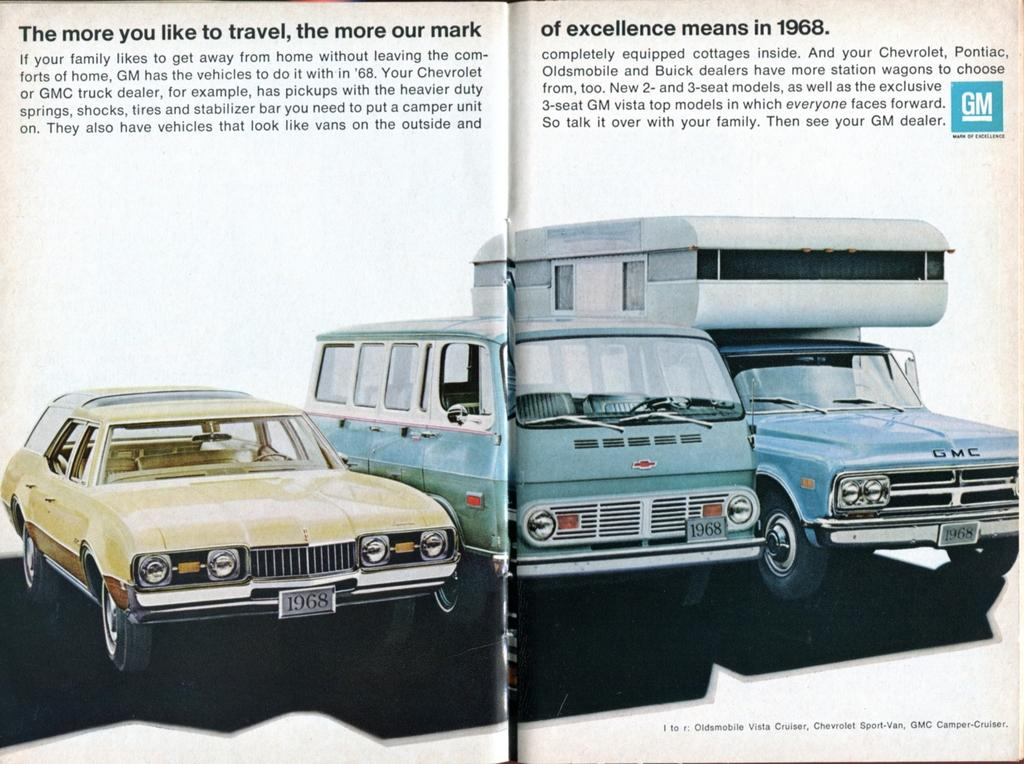Provide a one-sentence caption for the provided image. A 2-page GM ad from 1968 promotes their mark of excellence and features several vehicles. 